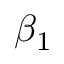Convert formula to latex. <formula><loc_0><loc_0><loc_500><loc_500>\beta _ { 1 }</formula> 